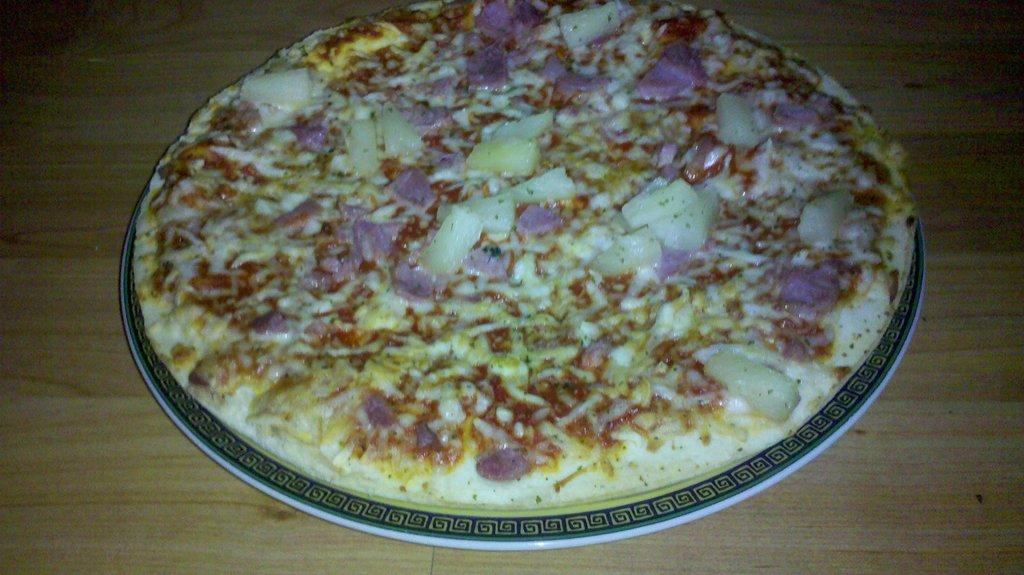What type of food is depicted on the plate in the image? There is a pizza place on a plate in the image. What type of approval does the pizza place need to follow the new rule in the image? There is no mention of any approval or rule in the image; it simply shows a pizza place on a plate. 